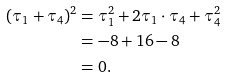<formula> <loc_0><loc_0><loc_500><loc_500>( \tau _ { 1 } + \tau _ { 4 } ) ^ { 2 } & = \tau _ { 1 } ^ { 2 } + 2 \tau _ { 1 } \cdot \tau _ { 4 } + \tau _ { 4 } ^ { 2 } \\ & = - 8 + 1 6 - 8 \\ & = 0 .</formula> 